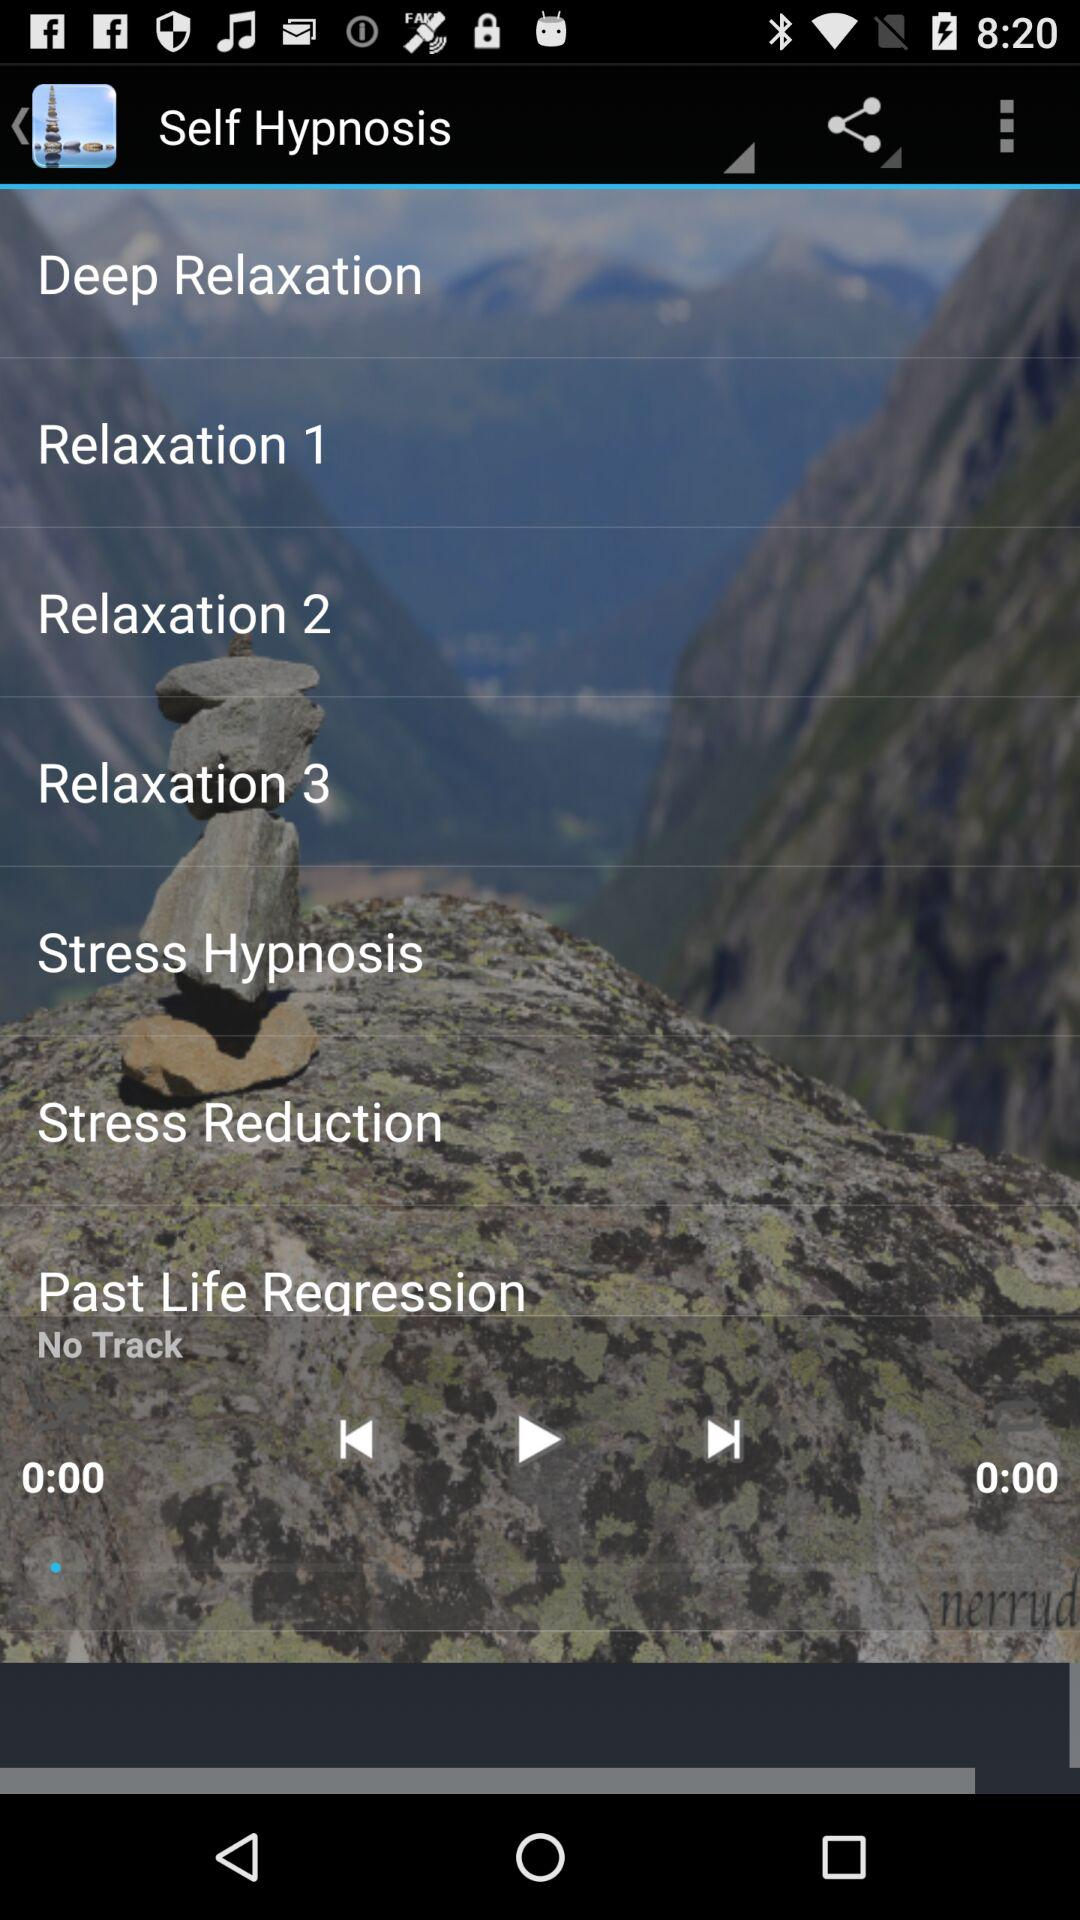What is the app name?
When the provided information is insufficient, respond with <no answer>. <no answer> 